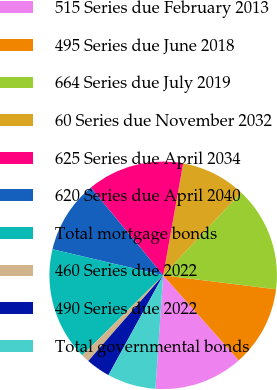Convert chart to OTSL. <chart><loc_0><loc_0><loc_500><loc_500><pie_chart><fcel>515 Series due February 2013<fcel>495 Series due June 2018<fcel>664 Series due July 2019<fcel>60 Series due November 2032<fcel>625 Series due April 2034<fcel>620 Series due April 2040<fcel>Total mortgage bonds<fcel>460 Series due 2022<fcel>490 Series due 2022<fcel>Total governmental bonds<nl><fcel>12.64%<fcel>11.49%<fcel>14.94%<fcel>9.2%<fcel>13.79%<fcel>10.34%<fcel>16.09%<fcel>1.16%<fcel>3.45%<fcel>6.9%<nl></chart> 